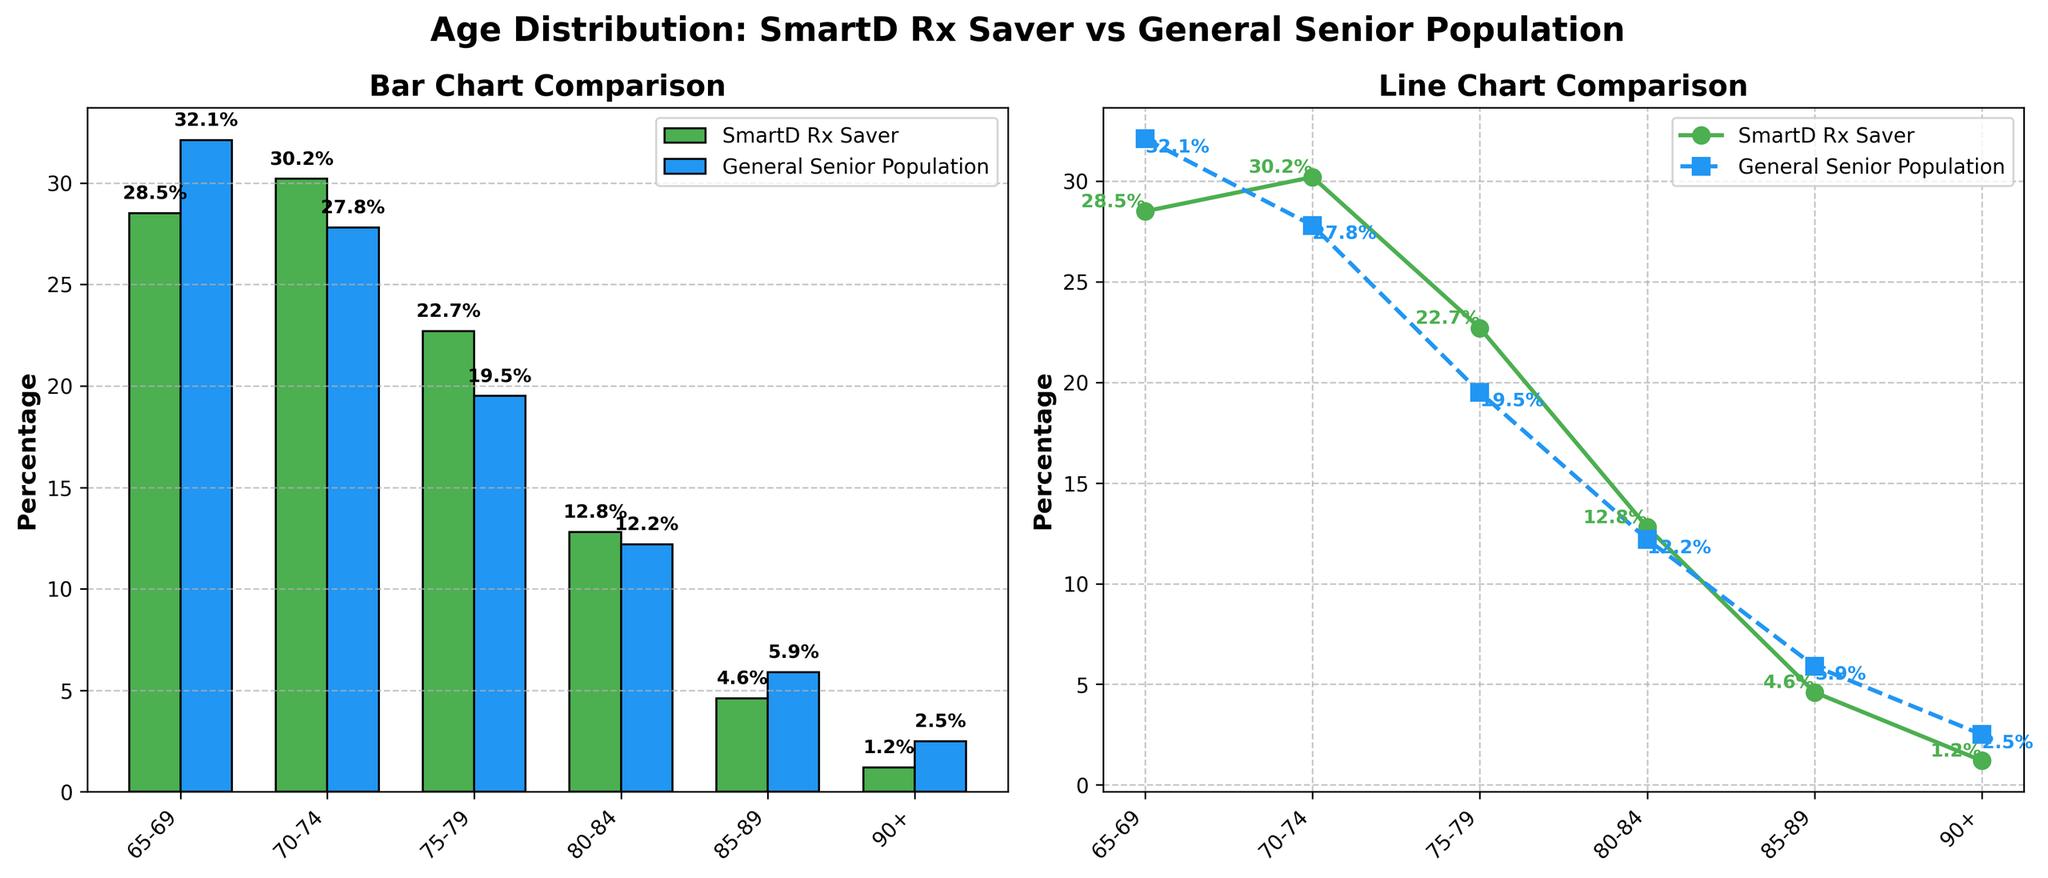What is the percentage difference between the '65-69' age group in the SmartD Rx Saver plan and the general senior population? The percentage for the '65-69' age group in the SmartD Rx Saver plan is 28.5%, and for the general senior population, it is 32.1%. The difference is calculated as 32.1% - 28.5% = 3.6%.
Answer: 3.6% Which age group has the highest percentage in the SmartD Rx Saver plan, and what is that percentage? The highest percentage in the SmartD Rx Saver plan is found in the '70-74' age group, which is 30.2%.
Answer: '70-74', 30.2% How does the percentage of enrollees aged '90+' in the SmartD Rx Saver plan compare to the general senior population? In the '90+' age group, the SmartD Rx Saver plan has 1.2%, while the general senior population has 2.5%. The general senior population has a higher percentage.
Answer: The general senior population is higher What is the combined percentage for the '75-79' and '80-84' age groups in the SmartD Rx Saver plan? The percentage for the '75-79' age group is 22.7%, and for '80-84', it is 12.8%. Combined, the percentage is 22.7% + 12.8% = 35.5%.
Answer: 35.5% In which age group is the difference between the SmartD Rx Saver plan and the general senior population the smallest? The smallest difference is found in the '80-84' age group. The percentages are 12.8% for the SmartD Rx Saver plan and 12.2% for the general senior population, resulting in a difference of 0.6%.
Answer: '80-84', 0.6% What trend is observed in the line plot for the SmartD Rx Saver plan from the '65-69' age group to the '85-89' age group? The trend shows a decrease in the percentage from the '65-69' age group (28.5%) to the '85-89' age group (4.6%). This indicates a downward trend as age increases.
Answer: Downward trend What is the average percentage of enrollees in the '75-79' and '80-84' age groups in the general senior population? The percentages for the '75-79' and '80-84' age groups are 19.5% and 12.2%, respectively. The average is calculated as (19.5% + 12.2%) / 2 = 15.85%.
Answer: 15.85% For which age group is the percentage difference between the SmartD Rx Saver plan and the general senior population the largest, and what is that difference? The largest difference is for the '90+' age group. The percentage for the SmartD Rx Saver plan is 1.2%, and for the general senior population, it is 2.5%. The difference is 2.5% - 1.2% = 1.3%.
Answer: '90+', 1.3% How do the percentage distributions of the '70-74' age group compare visually in the bar chart and line plot? In both the bar chart and the line plot, the '70-74' age group shows the SmartD Rx Saver plan having a higher percentage (30.2%) compared to the general senior population (27.8%). In bars, SmartD is taller and in lines, it is higher.
Answer: SmartD is higher in both plots What is the total percentage of enrollees for people aged 75 and above in the SmartD Rx Saver plan? Adding the percentages for '75-79' (22.7%), '80-84' (12.8%), '85-89' (4.6%), and '90+' (1.2%) gives 22.7% + 12.8% + 4.6% + 1.2% = 41.3%.
Answer: 41.3% 